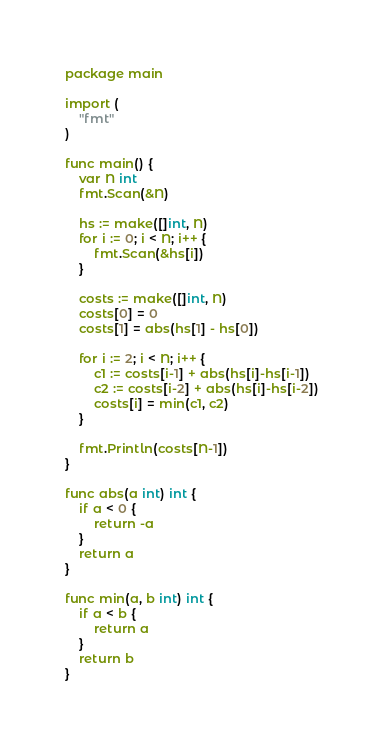Convert code to text. <code><loc_0><loc_0><loc_500><loc_500><_Go_>package main

import (
	"fmt"
)

func main() {
	var N int
	fmt.Scan(&N)

	hs := make([]int, N)
	for i := 0; i < N; i++ {
		fmt.Scan(&hs[i])
	}

	costs := make([]int, N)
	costs[0] = 0
	costs[1] = abs(hs[1] - hs[0])

	for i := 2; i < N; i++ {
		c1 := costs[i-1] + abs(hs[i]-hs[i-1])
		c2 := costs[i-2] + abs(hs[i]-hs[i-2])
		costs[i] = min(c1, c2)
	}

	fmt.Println(costs[N-1])
}

func abs(a int) int {
	if a < 0 {
		return -a
	}
	return a
}

func min(a, b int) int {
	if a < b {
		return a
	}
	return b
}
</code> 